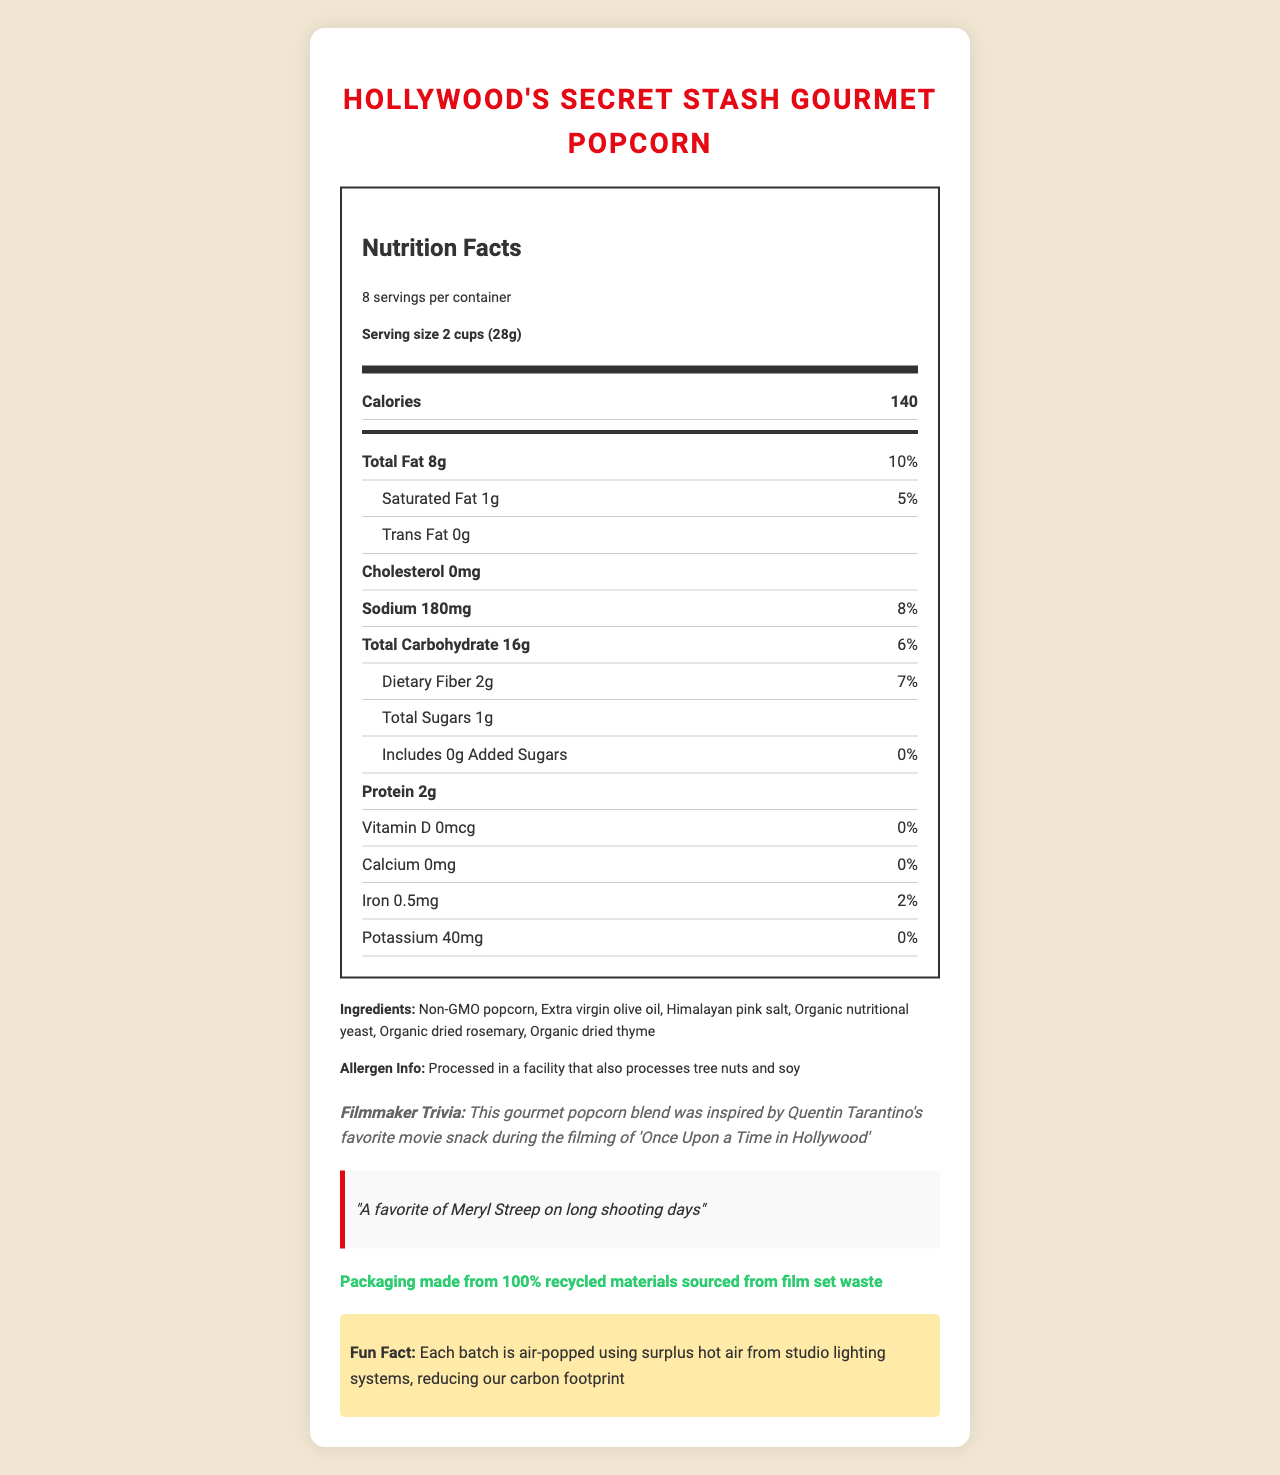What is the serving size for "Hollywood's Secret Stash Gourmet Popcorn"? The document states under "Serving size" that it is 2 cups (28g).
Answer: 2 cups (28g) How many calories are there per serving? The document lists calories per serving as 140.
Answer: 140 What type of oil is used in this popcorn? The ingredients list "Extra virgin olive oil".
Answer: Extra virgin olive oil What is the total fat content per serving? The document specifies "Total Fat" as 8g.
Answer: 8g What is the daily value percentage of sodium per serving? Under sodium, the daily value is listed as 8%.
Answer: 8% Which well-known director inspired this gourmet popcorn blend? The filmmaker trivia section mentions Quentin Tarantino's favorite movie snack.
Answer: Quentin Tarantino How much protein is in one serving of this popcorn? The document lists protein as 2g.
Answer: 2g How many servings are there per container of this popcorn? A. 6 B. 8 C. 10 D. 12 The document indicates "8 servings per container".
Answer: B. 8 What is the allergen-related information mentioned in the document? A. Contains peanuts B. Gluten-free C. Processed in a facility that also processes tree nuts and soy The allergen info specifies that it is processed in a facility that processes tree nuts and soy.
Answer: C. Processed in a facility that also processes tree nuts and soy Which celebrity is mentioned as a fan of this popcorn? The celebrity endorsement section mentions Meryl Streep.
Answer: Meryl Streep Is there any cholesterol in this gourmet popcorn? (Yes/No) The document states that there is 0mg of cholesterol.
Answer: No Summarize the main idea of the document. The document includes comprehensive details about the product from nutrition to sustainability and celebrity endorsements.
Answer: This document provides detailed nutrition facts, ingredients, allergen information, and interesting trivia about "Hollywood's Secret Stash Gourmet Popcorn". It notes that the popcorn is enjoyed by celebrities, inspired by Quentin Tarantino, and produced sustainably. How much Vitamin D is in one serving? The document states that Vitamin D content is 0mcg.
Answer: 0mcg Describe one sustainability feature of "Hollywood's Secret Stash Gourmet Popcorn". The sustainability note mentions the use of recycled materials for packaging.
Answer: The packaging is made from 100% recycled materials sourced from film set waste. What is the amount of total carbohydrate per serving? The document lists total carbohydrate as 16g per serving.
Answer: 16g Who endorsed this gourmet popcorn for long shooting days? The celebrity endorsement section mentions Meryl Streep.
Answer: Meryl Streep What specific ingredient adds flavor using nutritional yeast? The ingredients list "Organic nutritional yeast".
Answer: Organic nutritional yeast How many grams of added sugars are in this popcorn? The document states "Includes 0g Added Sugars".
Answer: 0g What unique method is used to air-pop each batch of popcorn? The fun fact mentions that each batch is air-popped using surplus hot air from studio lighting systems.
Answer: Surplus hot air from studio lighting systems What is the total amount of iron in this popcorn? The document lists iron content as 0.5mg.
Answer: 0.5mg What is the flavor inspiration for this popcorn attributed to? The filmmaker trivia section mentions Quentin Tarantino's favorite movie snack.
Answer: Quentin Tarantino's favorite movie snack What is the highest daily value percentage listed for any nutrient? The total fat content has a daily value of 10%, which is the highest percentage given.
Answer: 10% (Total Fat) What company manufactures "Hollywood's Secret Stash Gourmet Popcorn"? The document does not provide information about the manufacturing company.
Answer: Cannot be determined 